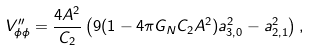<formula> <loc_0><loc_0><loc_500><loc_500>V ^ { \prime \prime } _ { \phi \phi } = \frac { 4 A ^ { 2 } } { C _ { 2 } } \left ( 9 ( 1 - 4 \pi G _ { N } C _ { 2 } A ^ { 2 } ) a _ { 3 , 0 } ^ { 2 } - a _ { 2 , 1 } ^ { 2 } \right ) ,</formula> 